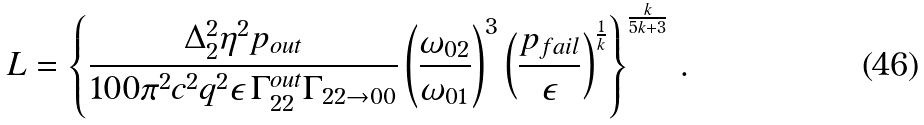Convert formula to latex. <formula><loc_0><loc_0><loc_500><loc_500>L = \left \{ \frac { \Delta _ { 2 } ^ { 2 } \eta ^ { 2 } p _ { o u t } } { 1 0 0 \pi ^ { 2 } c ^ { 2 } q ^ { 2 } \epsilon \, \Gamma _ { 2 2 } ^ { o u t } \Gamma _ { 2 2 \rightarrow 0 0 } } \left ( \frac { \omega _ { 0 2 } } { \omega _ { 0 1 } } \right ) ^ { 3 } \left ( \frac { p _ { f a i l } } { \epsilon } \right ) ^ { \frac { 1 } { k } } \right \} ^ { \frac { k } { 5 k + 3 } } \, .</formula> 